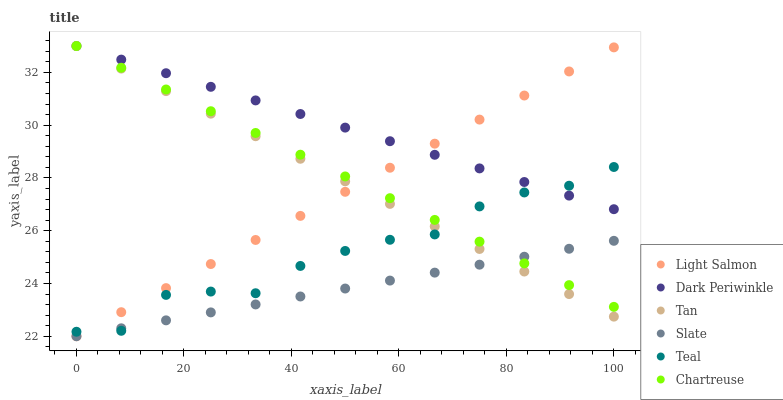Does Slate have the minimum area under the curve?
Answer yes or no. Yes. Does Dark Periwinkle have the maximum area under the curve?
Answer yes or no. Yes. Does Chartreuse have the minimum area under the curve?
Answer yes or no. No. Does Chartreuse have the maximum area under the curve?
Answer yes or no. No. Is Light Salmon the smoothest?
Answer yes or no. Yes. Is Teal the roughest?
Answer yes or no. Yes. Is Slate the smoothest?
Answer yes or no. No. Is Slate the roughest?
Answer yes or no. No. Does Light Salmon have the lowest value?
Answer yes or no. Yes. Does Chartreuse have the lowest value?
Answer yes or no. No. Does Dark Periwinkle have the highest value?
Answer yes or no. Yes. Does Slate have the highest value?
Answer yes or no. No. Is Slate less than Dark Periwinkle?
Answer yes or no. Yes. Is Dark Periwinkle greater than Slate?
Answer yes or no. Yes. Does Slate intersect Light Salmon?
Answer yes or no. Yes. Is Slate less than Light Salmon?
Answer yes or no. No. Is Slate greater than Light Salmon?
Answer yes or no. No. Does Slate intersect Dark Periwinkle?
Answer yes or no. No. 